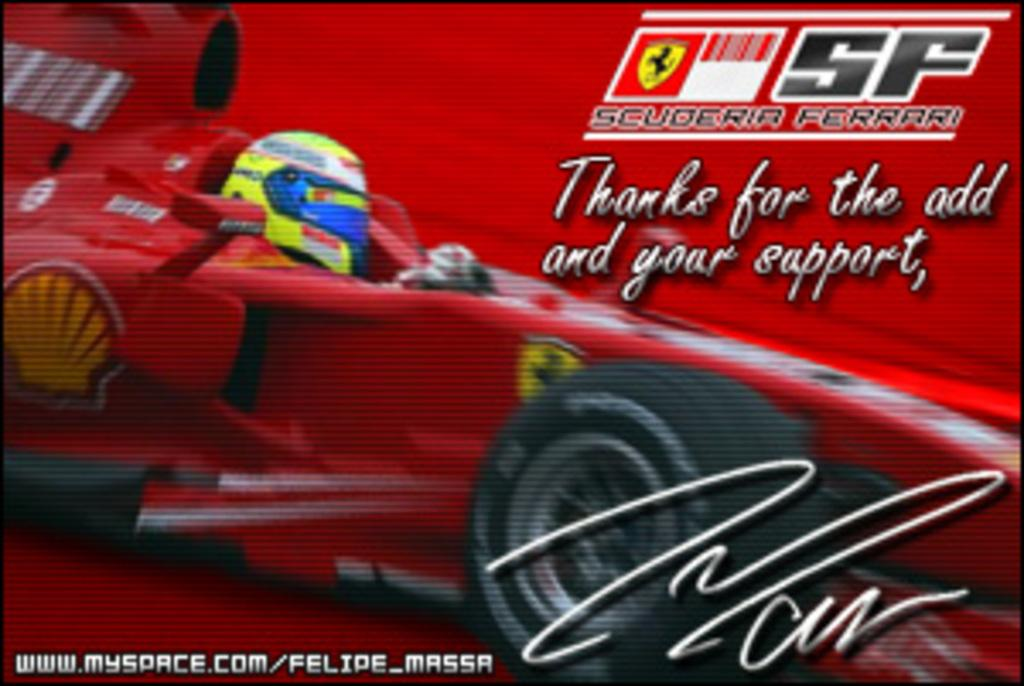What type of image is shown in the poster? The image is a poster depicting a car race. What is happening in the car race? A person is riding a car in the car race. What color is the car in the image? The car is red in color. What is the background color of the poster? The background of the poster is red. How many rabbits are participating in the car race in the image? There are no rabbits present in the image; it depicts a car race with a person riding a car. 